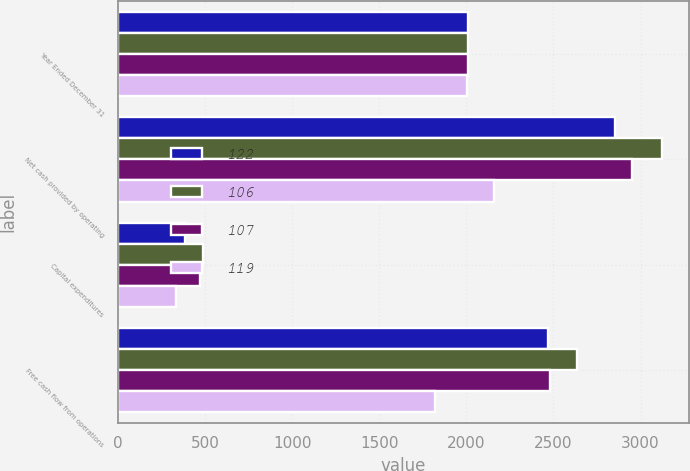Convert chart to OTSL. <chart><loc_0><loc_0><loc_500><loc_500><stacked_bar_chart><ecel><fcel>Year Ended December 31<fcel>Net cash provided by operating<fcel>Capital expenditures<fcel>Free cash flow from operations<nl><fcel>122<fcel>2009<fcel>2855<fcel>385<fcel>2470<nl><fcel>106<fcel>2008<fcel>3124<fcel>490<fcel>2634<nl><fcel>107<fcel>2007<fcel>2952<fcel>474<fcel>2478<nl><fcel>119<fcel>2006<fcel>2156<fcel>334<fcel>1822<nl></chart> 